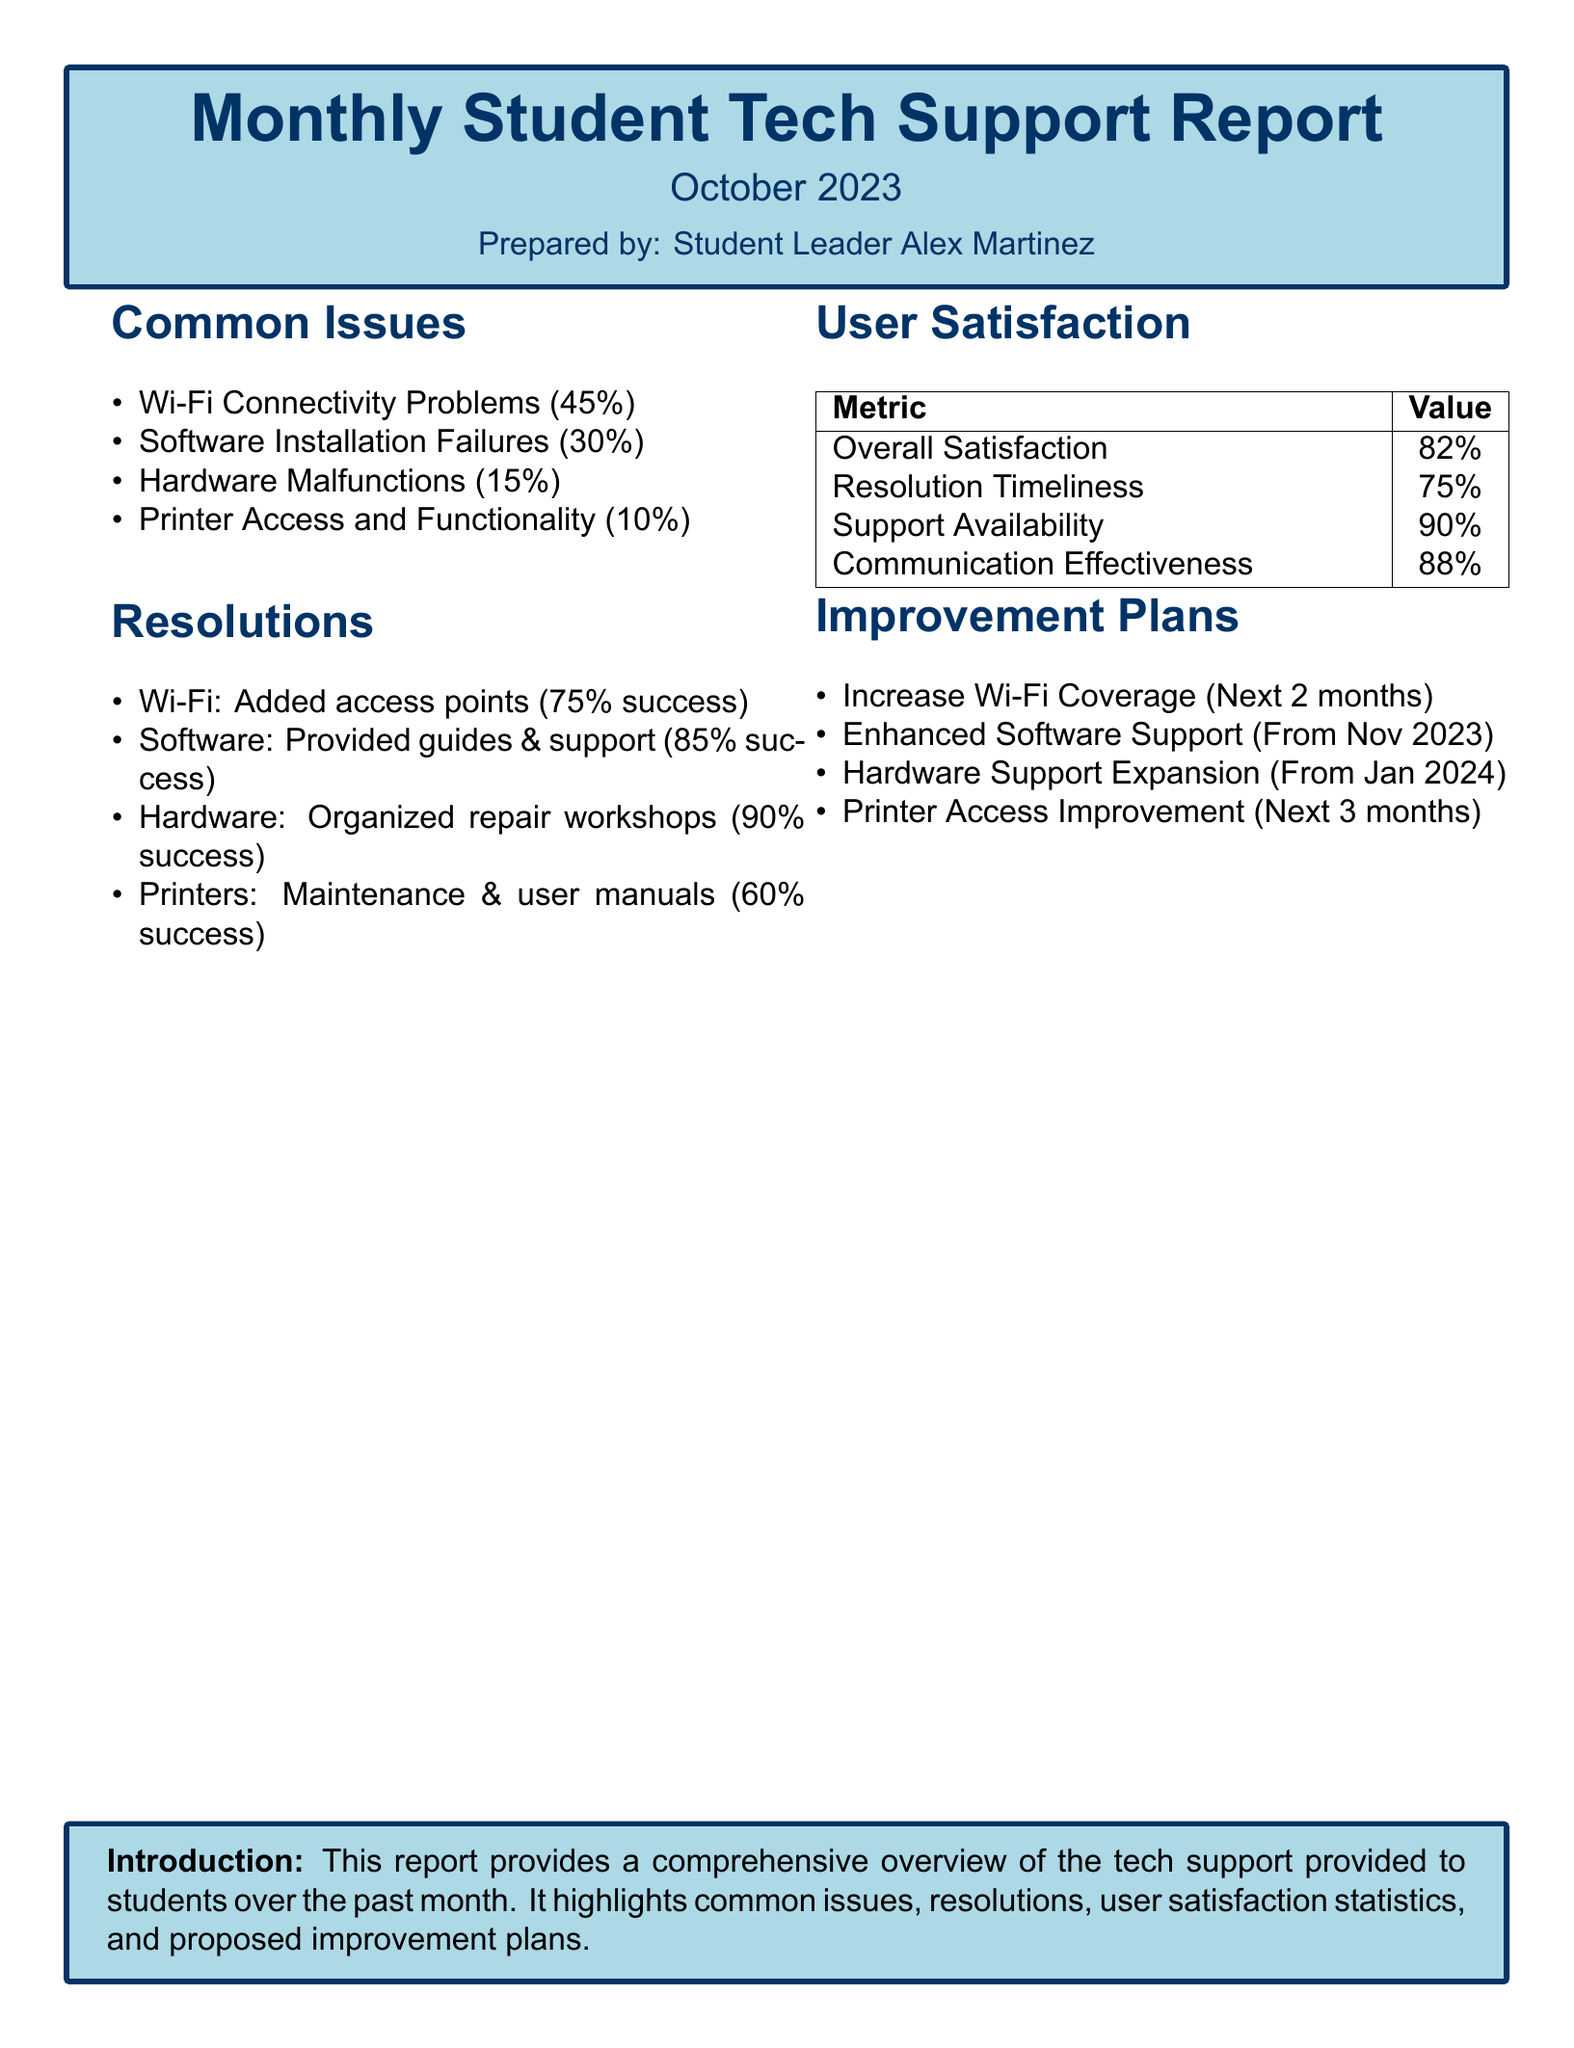what is the most common issue reported? The document states that Wi-Fi Connectivity Problems account for 45% of the reported issues.
Answer: Wi-Fi Connectivity Problems what percentage of users were satisfied overall? The report includes a metric for overall satisfaction, which is specified as 82%.
Answer: 82% how many success percentage was achieved for hardware resolutions? According to the resolutions section, hardware related issues achieved a 90% success rate in terms of resolutions.
Answer: 90% what is one of the improvement plans mentioned? The document lists multiple improvement plans, one being to Increase Wi-Fi Coverage within the next 2 months.
Answer: Increase Wi-Fi Coverage what is the success percentage for printer access resolutions? The report indicates that the success rate for printer access resolutions was 60%.
Answer: 60% which metric had the highest value for user satisfaction? The Communication Effectiveness received the highest user satisfaction score, which is 88%.
Answer: 88% what is the preparation date of the report? The document states that the report was prepared for October 2023.
Answer: October 2023 how many percentage of users faced hardware malfunctions? The document specifies that 15% of users reported hardware malfunctions as an issue.
Answer: 15% what is the resolution success percentage for software issues? According to the resolutions section, the success rate for software resolutions is indicated as 85%.
Answer: 85% 